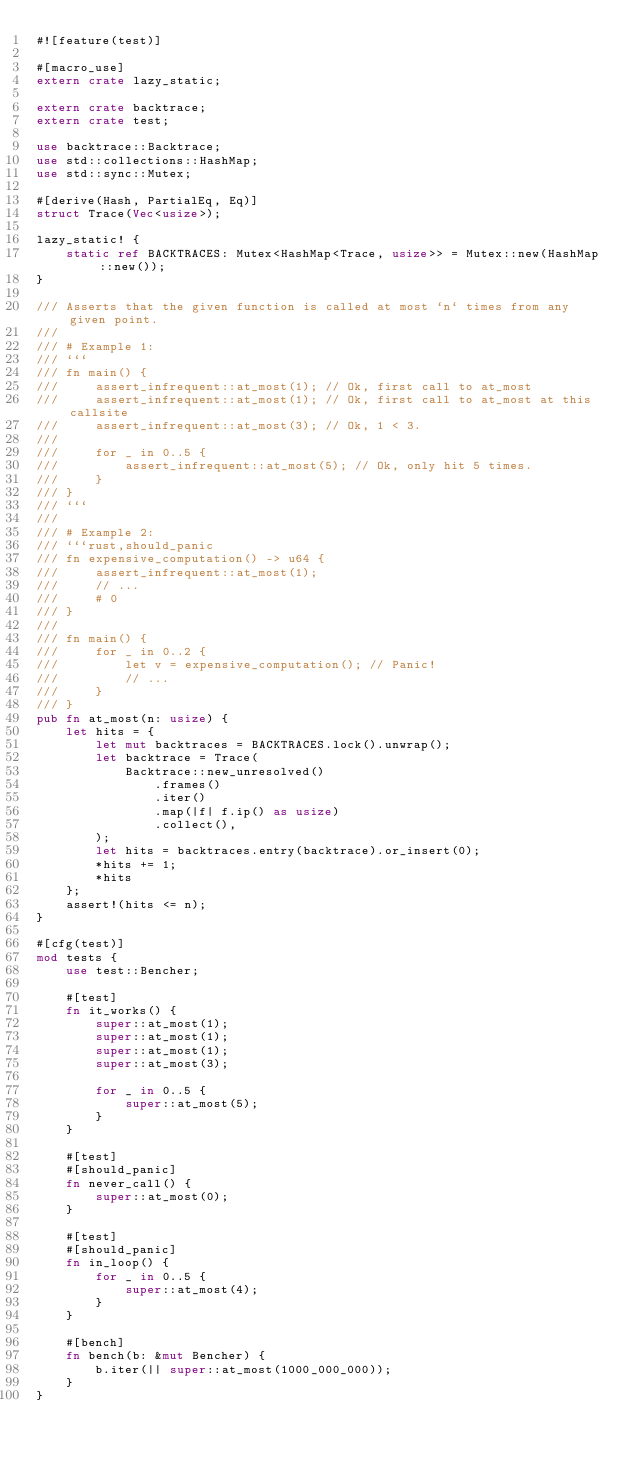Convert code to text. <code><loc_0><loc_0><loc_500><loc_500><_Rust_>#![feature(test)]

#[macro_use]
extern crate lazy_static;

extern crate backtrace;
extern crate test;

use backtrace::Backtrace;
use std::collections::HashMap;
use std::sync::Mutex;

#[derive(Hash, PartialEq, Eq)]
struct Trace(Vec<usize>);

lazy_static! {
    static ref BACKTRACES: Mutex<HashMap<Trace, usize>> = Mutex::new(HashMap::new());
}

/// Asserts that the given function is called at most `n` times from any given point.
///
/// # Example 1:
/// ```
/// fn main() {
///     assert_infrequent::at_most(1); // Ok, first call to at_most
///     assert_infrequent::at_most(1); // Ok, first call to at_most at this callsite
///     assert_infrequent::at_most(3); // Ok, 1 < 3.
///
///     for _ in 0..5 {
///         assert_infrequent::at_most(5); // Ok, only hit 5 times.
///     }
/// }
/// ```
///
/// # Example 2:
/// ```rust,should_panic
/// fn expensive_computation() -> u64 {
///     assert_infrequent::at_most(1);
///     // ...
///     # 0
/// }
///
/// fn main() {
///     for _ in 0..2 {
///         let v = expensive_computation(); // Panic!
///         // ...
///     }
/// }
pub fn at_most(n: usize) {
    let hits = {
        let mut backtraces = BACKTRACES.lock().unwrap();
        let backtrace = Trace(
            Backtrace::new_unresolved()
                .frames()
                .iter()
                .map(|f| f.ip() as usize)
                .collect(),
        );
        let hits = backtraces.entry(backtrace).or_insert(0);
        *hits += 1;
        *hits
    };
    assert!(hits <= n);
}

#[cfg(test)]
mod tests {
    use test::Bencher;

    #[test]
    fn it_works() {
        super::at_most(1);
        super::at_most(1);
        super::at_most(1);
        super::at_most(3);

        for _ in 0..5 {
            super::at_most(5);
        }
    }

    #[test]
    #[should_panic]
    fn never_call() {
        super::at_most(0);
    }

    #[test]
    #[should_panic]
    fn in_loop() {
        for _ in 0..5 {
            super::at_most(4);
        }
    }

    #[bench]
    fn bench(b: &mut Bencher) {
        b.iter(|| super::at_most(1000_000_000));
    }
}
</code> 